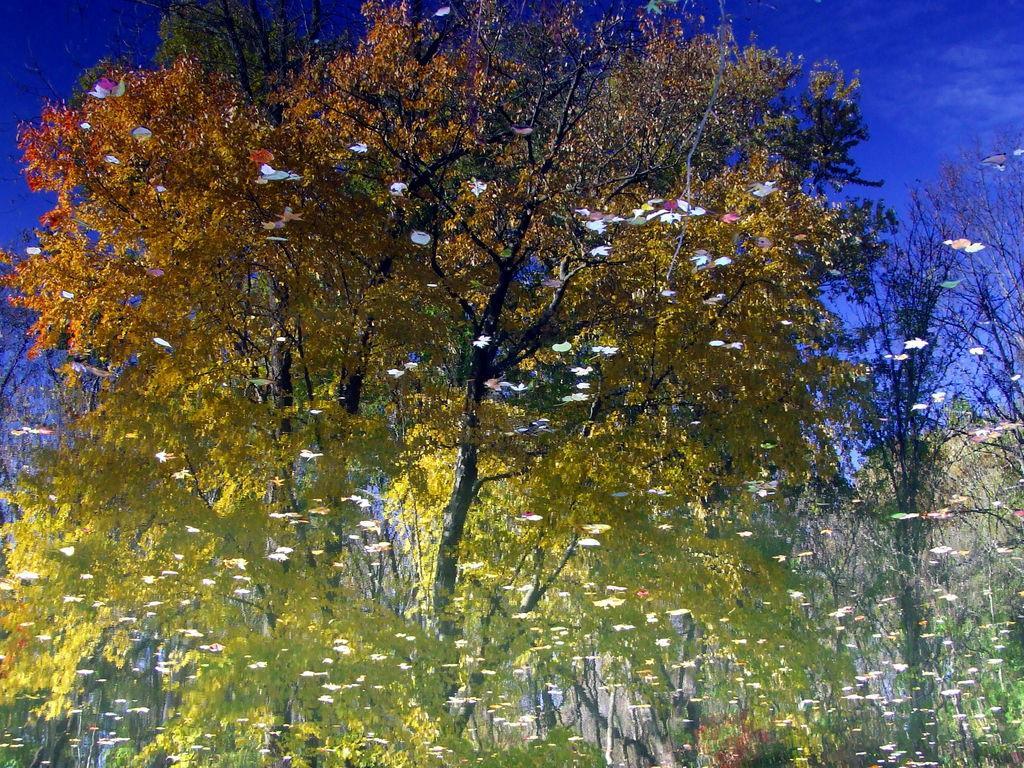Describe this image in one or two sentences. In this picture, it looks like the painting of trees and the sky. 